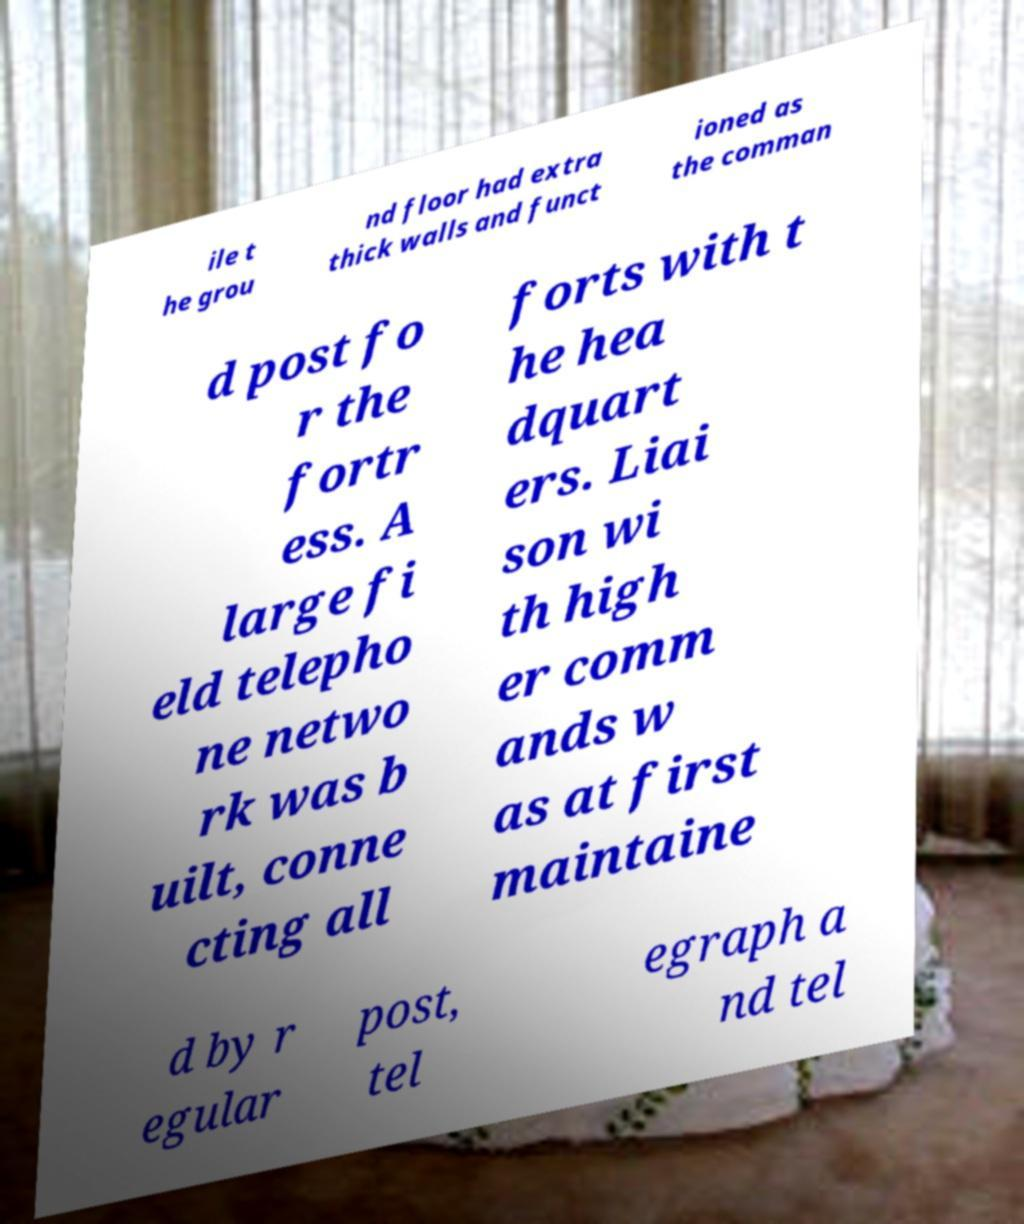I need the written content from this picture converted into text. Can you do that? ile t he grou nd floor had extra thick walls and funct ioned as the comman d post fo r the fortr ess. A large fi eld telepho ne netwo rk was b uilt, conne cting all forts with t he hea dquart ers. Liai son wi th high er comm ands w as at first maintaine d by r egular post, tel egraph a nd tel 